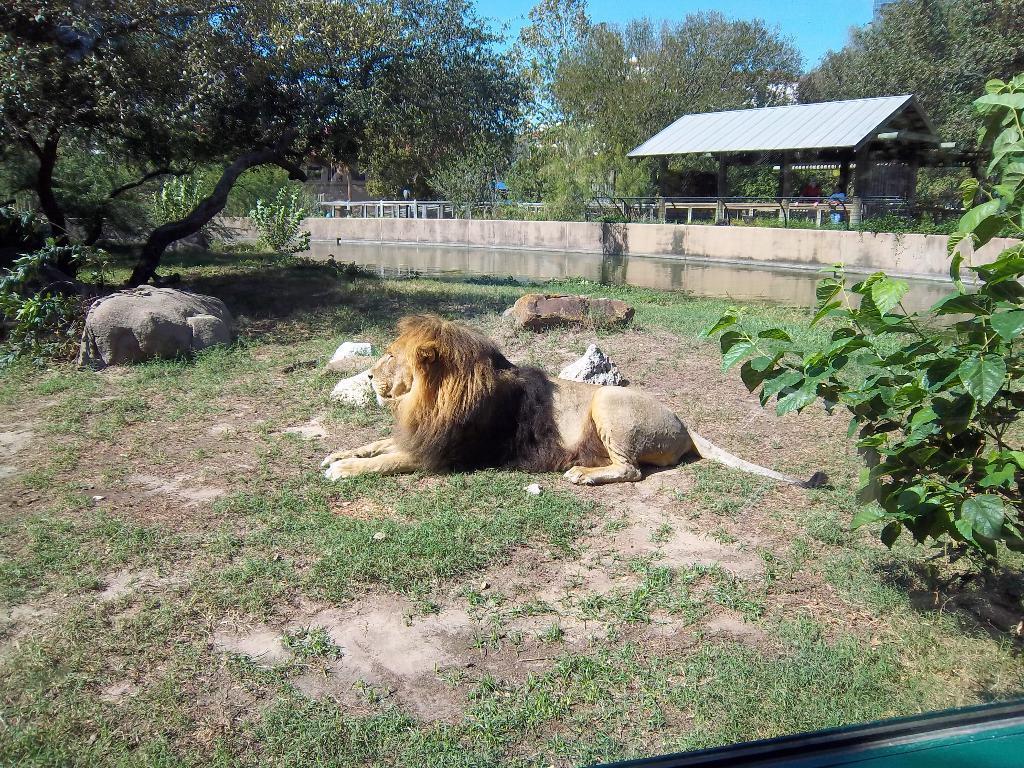Can you describe this image briefly? In this image I can see an animal on the ground. I can see an animal is in brown color. To the side I can see the rocks. In the background I can see the wall, shed and many trees. I can also see the blue sky in the back. 